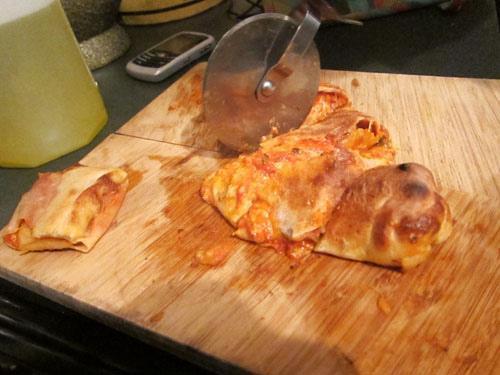How many pizzas can be seen?
Give a very brief answer. 2. 